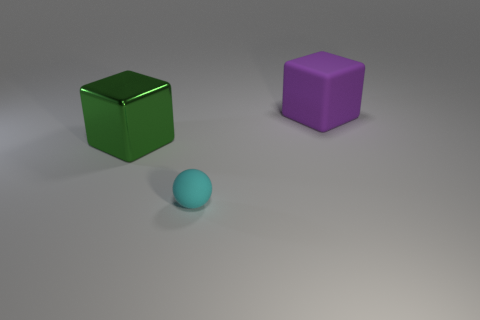Add 2 cyan rubber things. How many objects exist? 5 Subtract 1 cubes. How many cubes are left? 1 Subtract all green cubes. How many cubes are left? 1 Subtract all small cyan things. Subtract all large purple matte objects. How many objects are left? 1 Add 3 tiny cyan balls. How many tiny cyan balls are left? 4 Add 1 large blue blocks. How many large blue blocks exist? 1 Subtract 0 green cylinders. How many objects are left? 3 Subtract all spheres. How many objects are left? 2 Subtract all cyan cubes. Subtract all blue cylinders. How many cubes are left? 2 